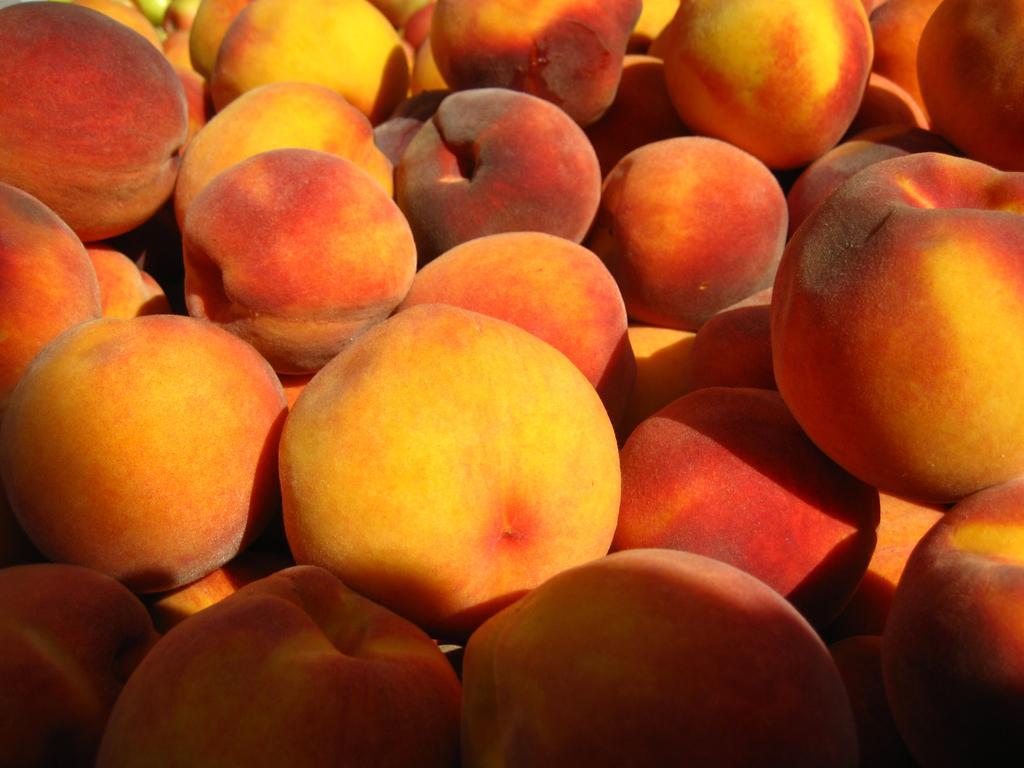Could you give a brief overview of what you see in this image? In this image we can see some fruits, which looks like apples. 